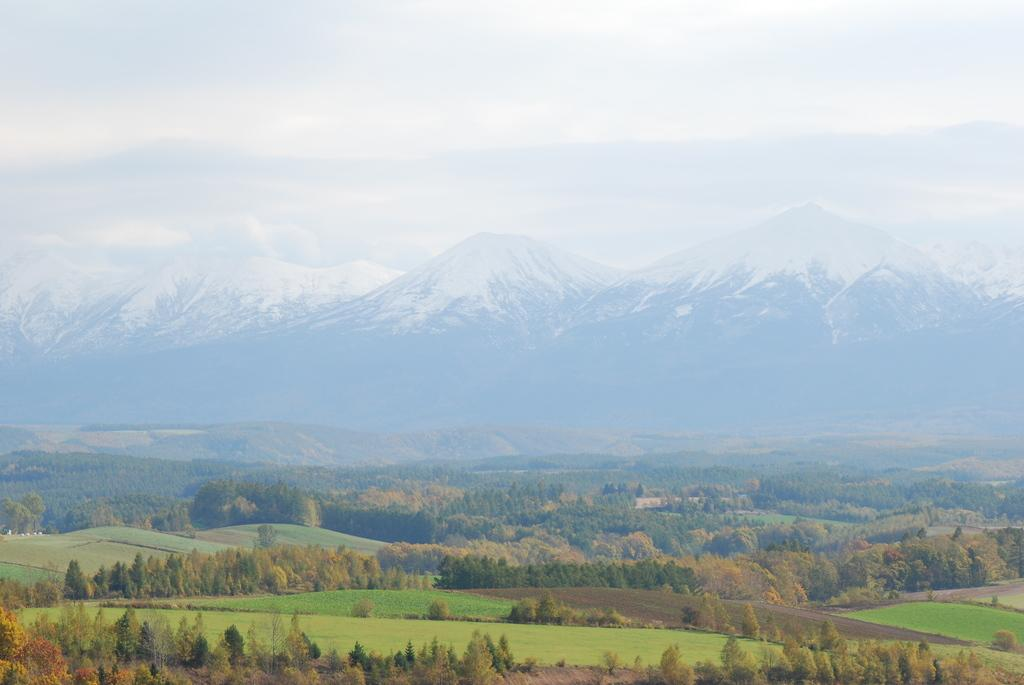What geographical feature is the main subject of the image? There is a mountain in the image. What type of vegetation can be seen on the mountain? There is grass on the mountain. What other natural elements are present in the image? There are trees in the image. What is the weather like on the mountain? There is snow in the image, which suggests a cold climate. What can be seen in the background of the image? The sky is visible in the image. What type of crime is being discussed by the committee in the image? There is no committee or crime present in the image; it features a mountain with grass, trees, snow, and a visible sky. 